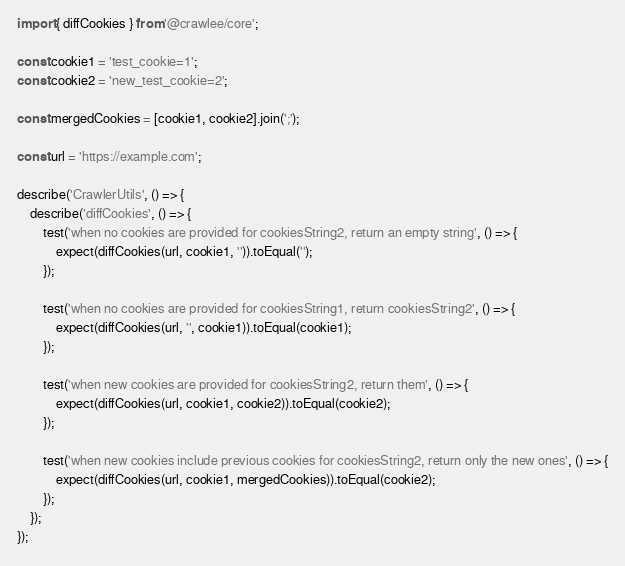Convert code to text. <code><loc_0><loc_0><loc_500><loc_500><_TypeScript_>import { diffCookies } from '@crawlee/core';

const cookie1 = 'test_cookie=1';
const cookie2 = 'new_test_cookie=2';

const mergedCookies = [cookie1, cookie2].join(';');

const url = 'https://example.com';

describe('CrawlerUtils', () => {
    describe('diffCookies', () => {
        test('when no cookies are provided for cookiesString2, return an empty string', () => {
            expect(diffCookies(url, cookie1, '')).toEqual('');
        });

        test('when no cookies are provided for cookiesString1, return cookiesString2', () => {
            expect(diffCookies(url, '', cookie1)).toEqual(cookie1);
        });

        test('when new cookies are provided for cookiesString2, return them', () => {
            expect(diffCookies(url, cookie1, cookie2)).toEqual(cookie2);
        });

        test('when new cookies include previous cookies for cookiesString2, return only the new ones', () => {
            expect(diffCookies(url, cookie1, mergedCookies)).toEqual(cookie2);
        });
    });
});
</code> 